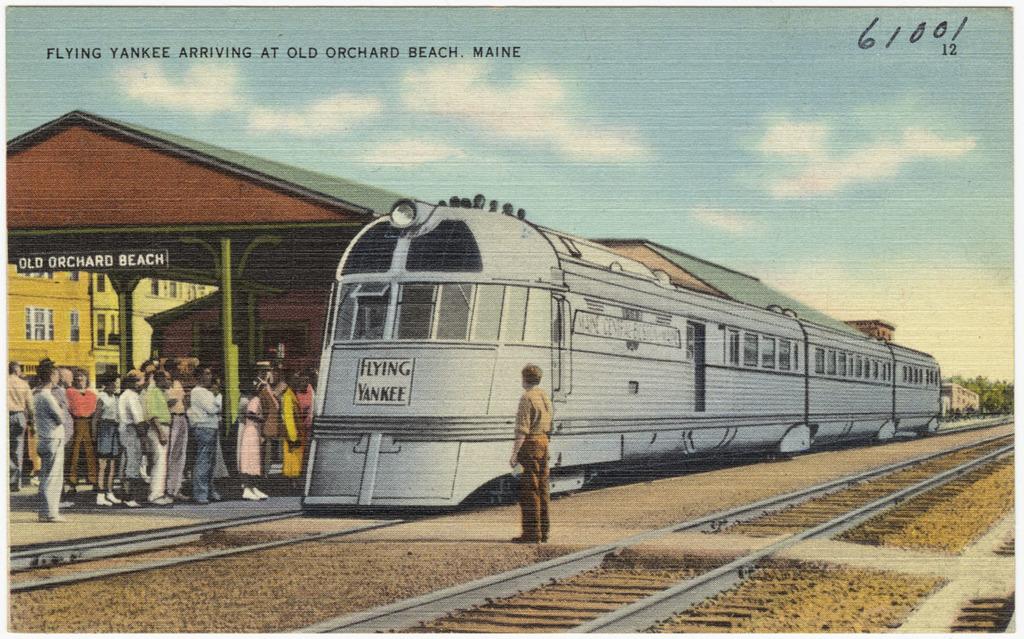What numbers appear in the top right?
Provide a succinct answer. 61001. What is the name of the performer?
Your answer should be compact. Unanswerable. 